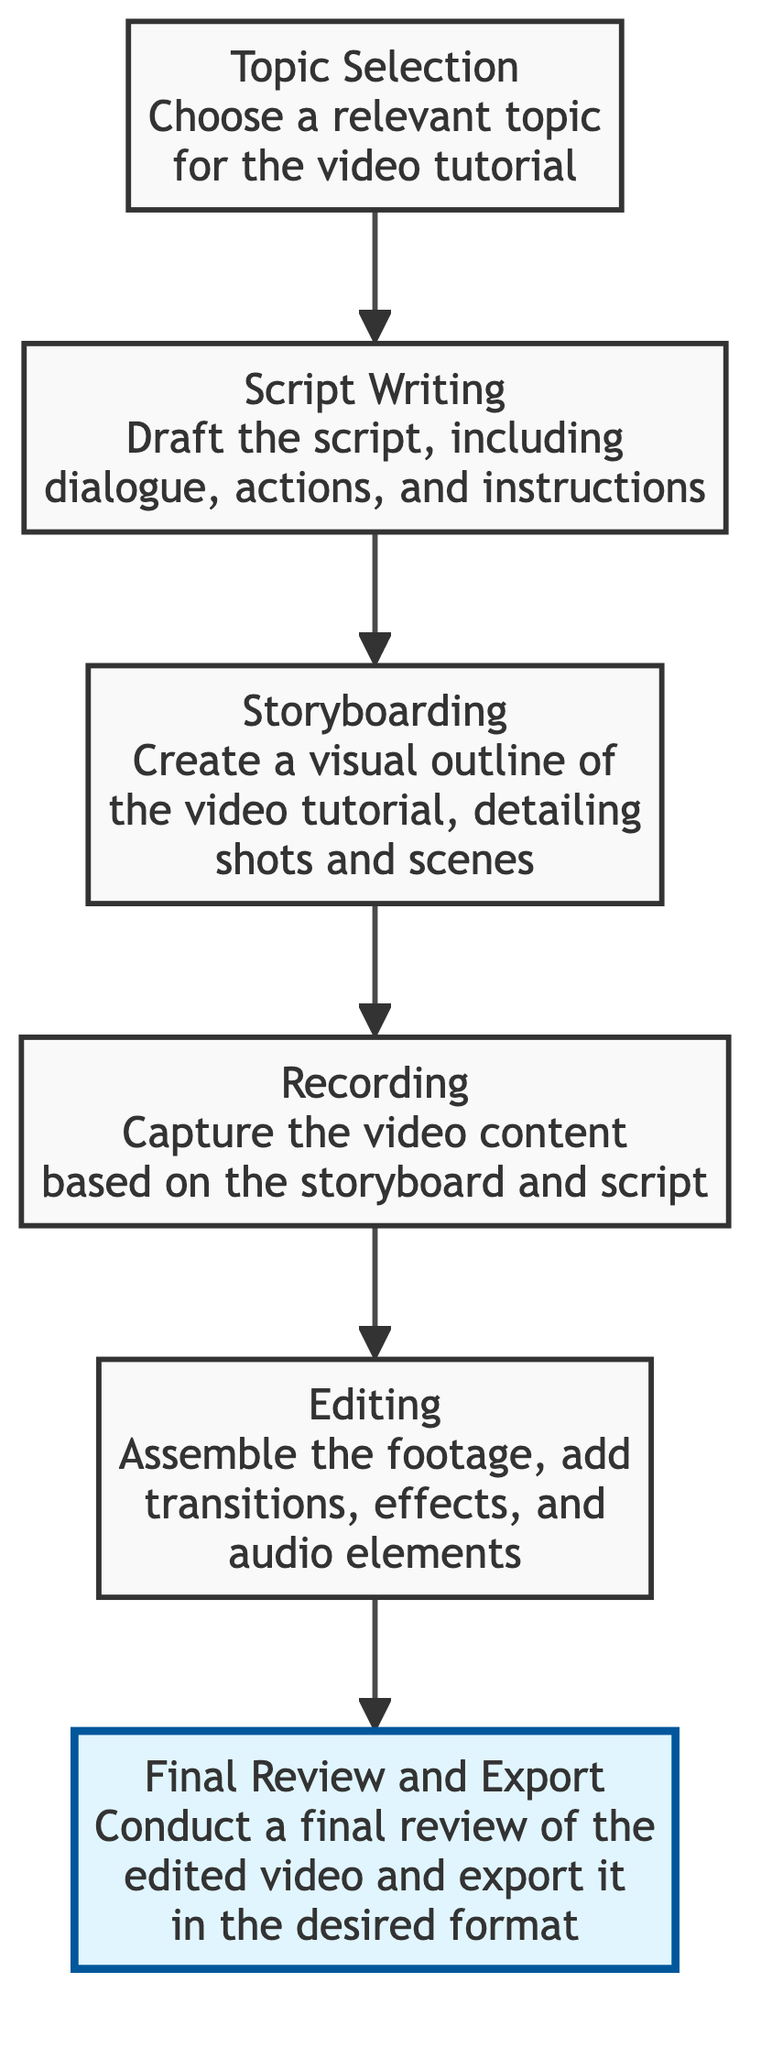What is the first step in developing a video tutorial? The first step, as shown in the diagram, is "Topic Selection" where you choose a relevant topic for the video tutorial.
Answer: Topic Selection How many nodes are in this diagram? By counting the steps from "Topic Selection" to "Final Review and Export," there are a total of six nodes in the diagram.
Answer: 6 What is the last step of the video tutorial process? The last step, as depicted in the flow chart, is "Final Review and Export" which involves conducting a final review of the edited video and exporting it in the desired format.
Answer: Final Review and Export Which step comes directly after "Script Writing"? Following "Script Writing" in the flow of the diagram is the step called "Storyboarding," where you create a visual outline detailing shots and scenes.
Answer: Storyboarding What does the "Editing" step involve? The "Editing" step involves assembling the footage, adding transitions, effects, and audio elements to complete the video.
Answer: Assemble footage, add transitions, effects, and audio elements How is "Recording" related to "Storyboarding"? "Recording" follows "Storyboarding" in the diagram, indicating that capturing video content is based on the previously created visual outline.
Answer: Recording follows Storyboarding Which two steps directly lead to the "Final Review and Export"? "Editing" is the step that directly leads to "Final Review and Export," indicating that once editing is complete, a final review and the export of the video follow.
Answer: Editing What is a prerequisite for the "Recording" step? The prerequisite for the "Recording" step is "Storyboarding," as the video content must be captured based on the storyboard and script previously created.
Answer: Storyboarding What action is performed during "Script Writing"? During "Script Writing," the action performed is drafting the script, which includes dialogue, actions, and instructions necessary for the video tutorial.
Answer: Draft the script 